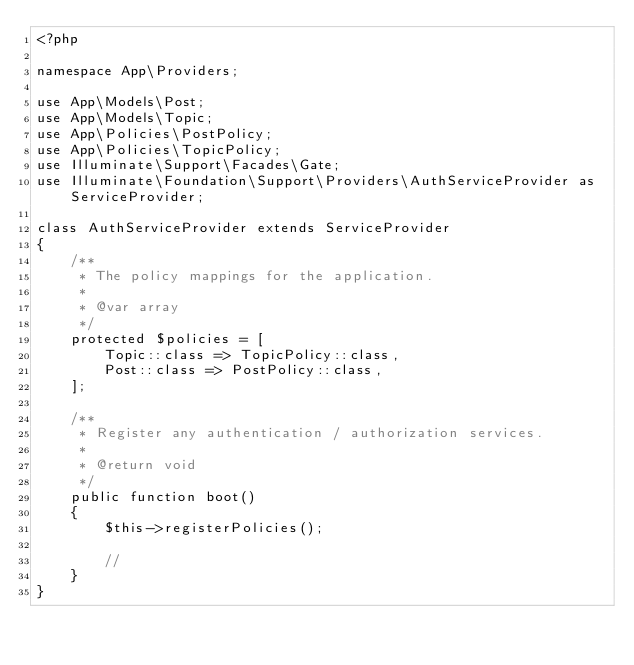<code> <loc_0><loc_0><loc_500><loc_500><_PHP_><?php

namespace App\Providers;

use App\Models\Post;
use App\Models\Topic;
use App\Policies\PostPolicy;
use App\Policies\TopicPolicy;
use Illuminate\Support\Facades\Gate;
use Illuminate\Foundation\Support\Providers\AuthServiceProvider as ServiceProvider;

class AuthServiceProvider extends ServiceProvider
{
    /**
     * The policy mappings for the application.
     *
     * @var array
     */
    protected $policies = [
        Topic::class => TopicPolicy::class,
        Post::class => PostPolicy::class,
    ];

    /**
     * Register any authentication / authorization services.
     *
     * @return void
     */
    public function boot()
    {
        $this->registerPolicies();

        //
    }
}
</code> 